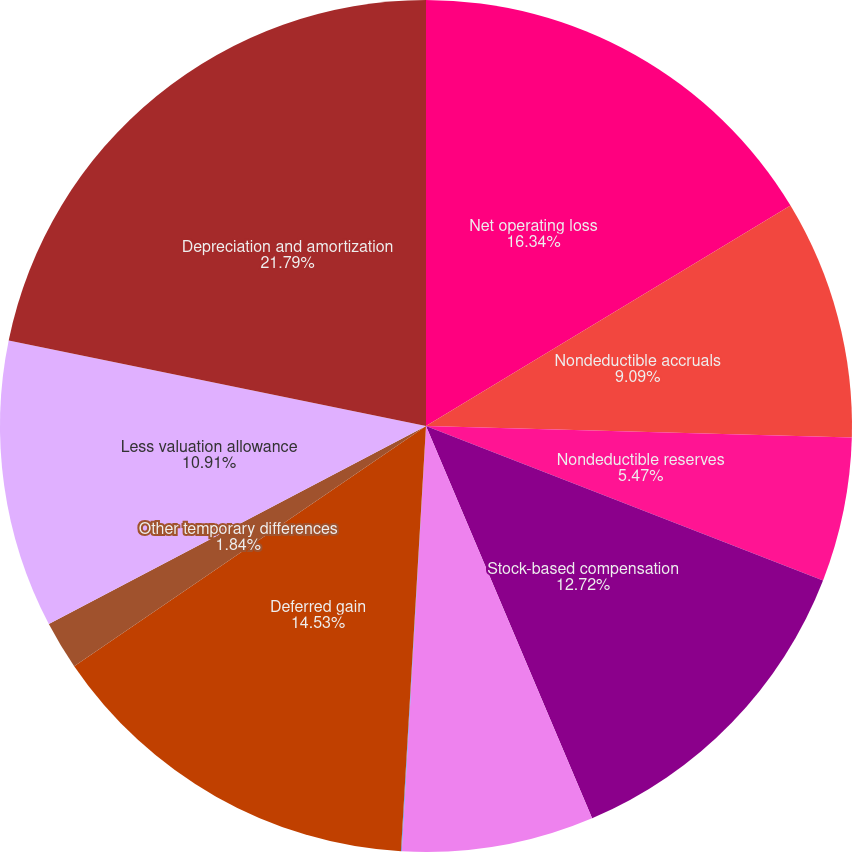Convert chart to OTSL. <chart><loc_0><loc_0><loc_500><loc_500><pie_chart><fcel>Net operating loss<fcel>Nondeductible accruals<fcel>Nondeductible reserves<fcel>Stock-based compensation<fcel>Research and other credits<fcel>Convertible Notes issuance<fcel>Deferred gain<fcel>Other temporary differences<fcel>Less valuation allowance<fcel>Depreciation and amortization<nl><fcel>16.34%<fcel>9.09%<fcel>5.47%<fcel>12.72%<fcel>7.28%<fcel>0.03%<fcel>14.53%<fcel>1.84%<fcel>10.91%<fcel>21.78%<nl></chart> 